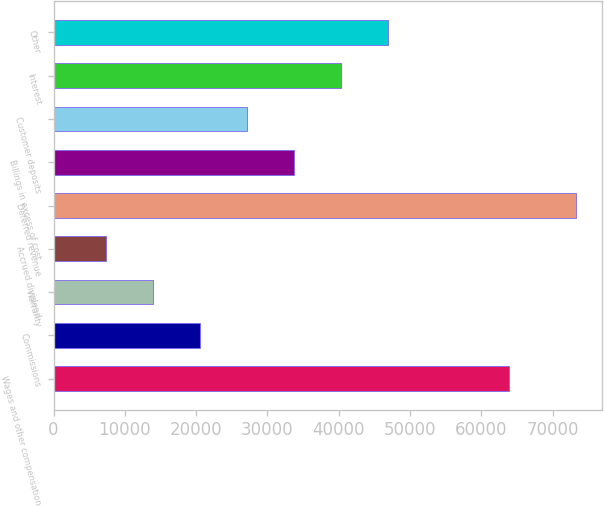Convert chart to OTSL. <chart><loc_0><loc_0><loc_500><loc_500><bar_chart><fcel>Wages and other compensation<fcel>Commissions<fcel>Warranty<fcel>Accrued dividend<fcel>Deferred revenue<fcel>Billings in excess of cost<fcel>Customer deposits<fcel>Interest<fcel>Other<nl><fcel>63878<fcel>20584<fcel>13993.5<fcel>7403<fcel>73308<fcel>33765<fcel>27174.5<fcel>40355.5<fcel>46946<nl></chart> 